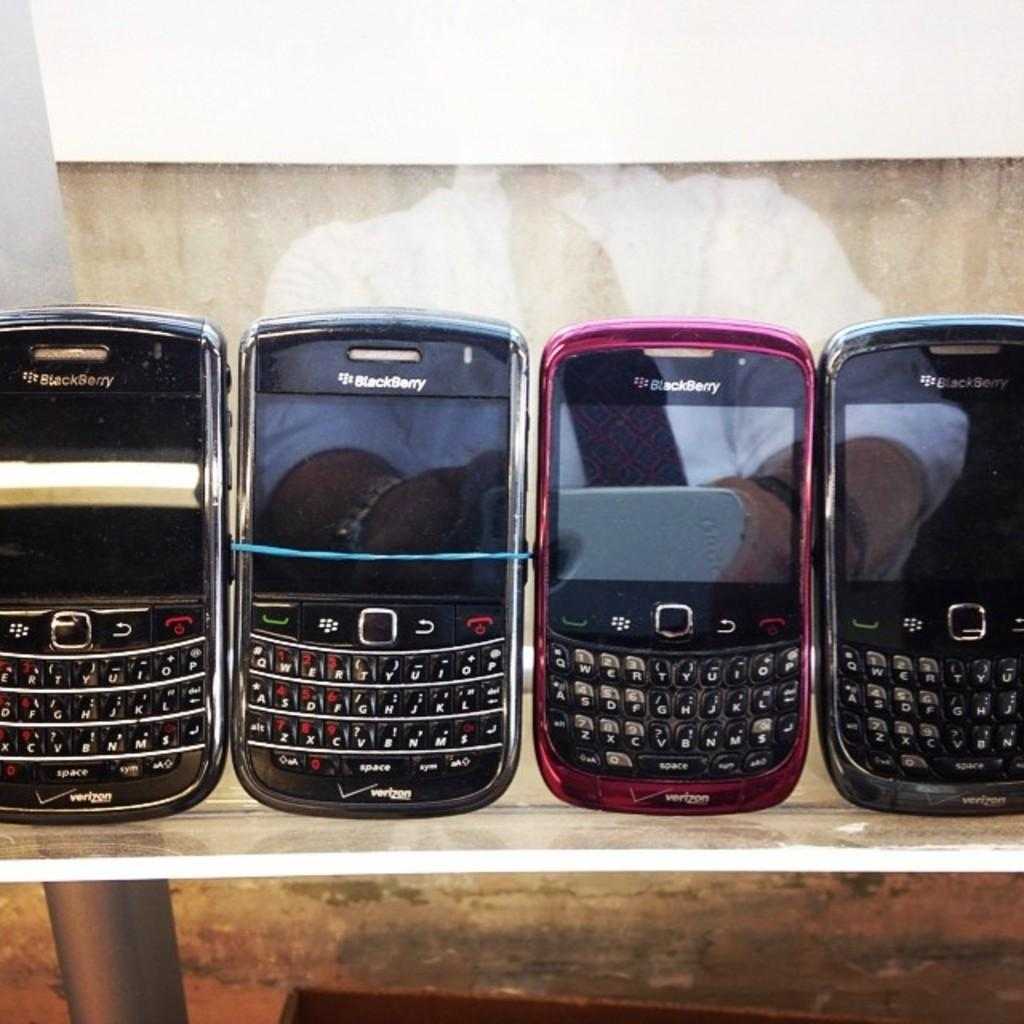<image>
Provide a brief description of the given image. Four Blackberry devices sit lined up on a table. 